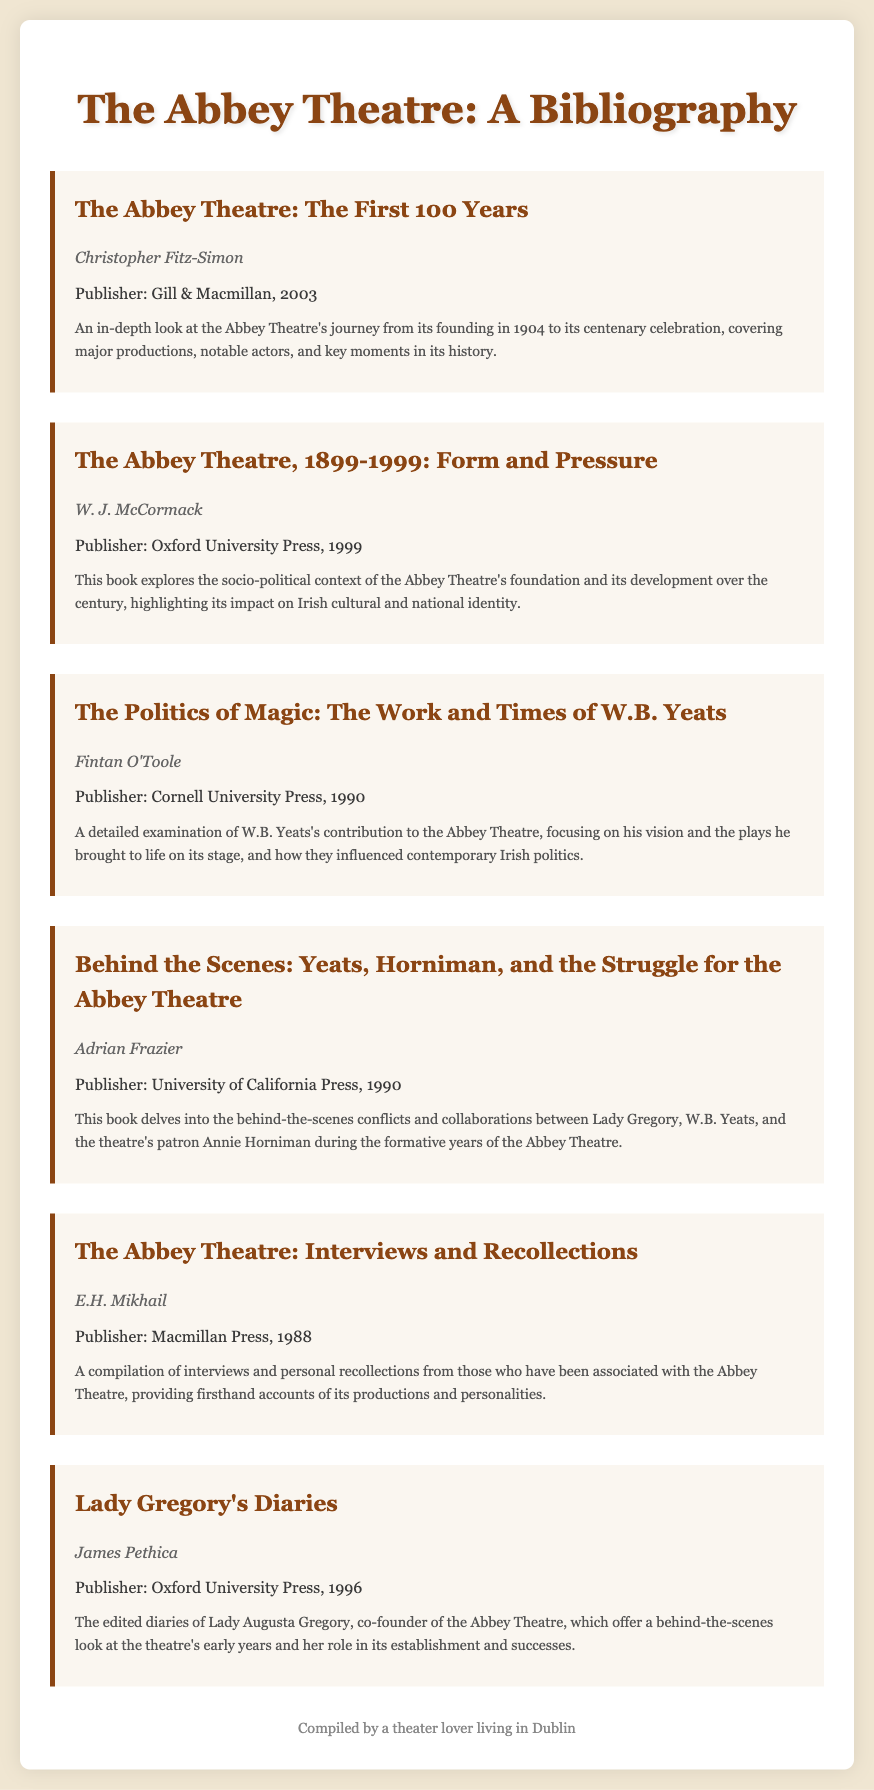What is the title of the first book listed? The title of the first book is listed at the top of the bibliography section.
Answer: The Abbey Theatre: The First 100 Years Who is the author of "The Abbey Theatre, 1899-1999: Form and Pressure"? This information is found directly below the title of the book in the document.
Answer: W. J. McCormack What year was "The Politics of Magic: The Work and Times of W.B. Yeats" published? The publication year is listed in association with the book's details in the bibliography.
Answer: 1990 Which book discusses the behind-the-scenes conflicts of the Abbey Theatre's founders? This information can be found in the summaries provided beneath the book titles.
Answer: Behind the Scenes: Yeats, Horniman, and the Struggle for the Abbey Theatre What is the publisher of "Lady Gregory's Diaries"? The publisher is noted in the specific book details provided in the bibliography document.
Answer: Oxford University Press How many years does "The Abbey Theatre: The First 100 Years" cover? By examining the title and the information about the book, you can deduce the years covered.
Answer: 100 years What type of content does "The Abbey Theatre: Interviews and Recollections" include? The summary provides insight into the type of content featured in the book.
Answer: Interviews and personal recollections Who co-founded the Abbey Theatre? The document provides this information within the summary related to Lady Gregory's diaries.
Answer: Lady Augusta Gregory 